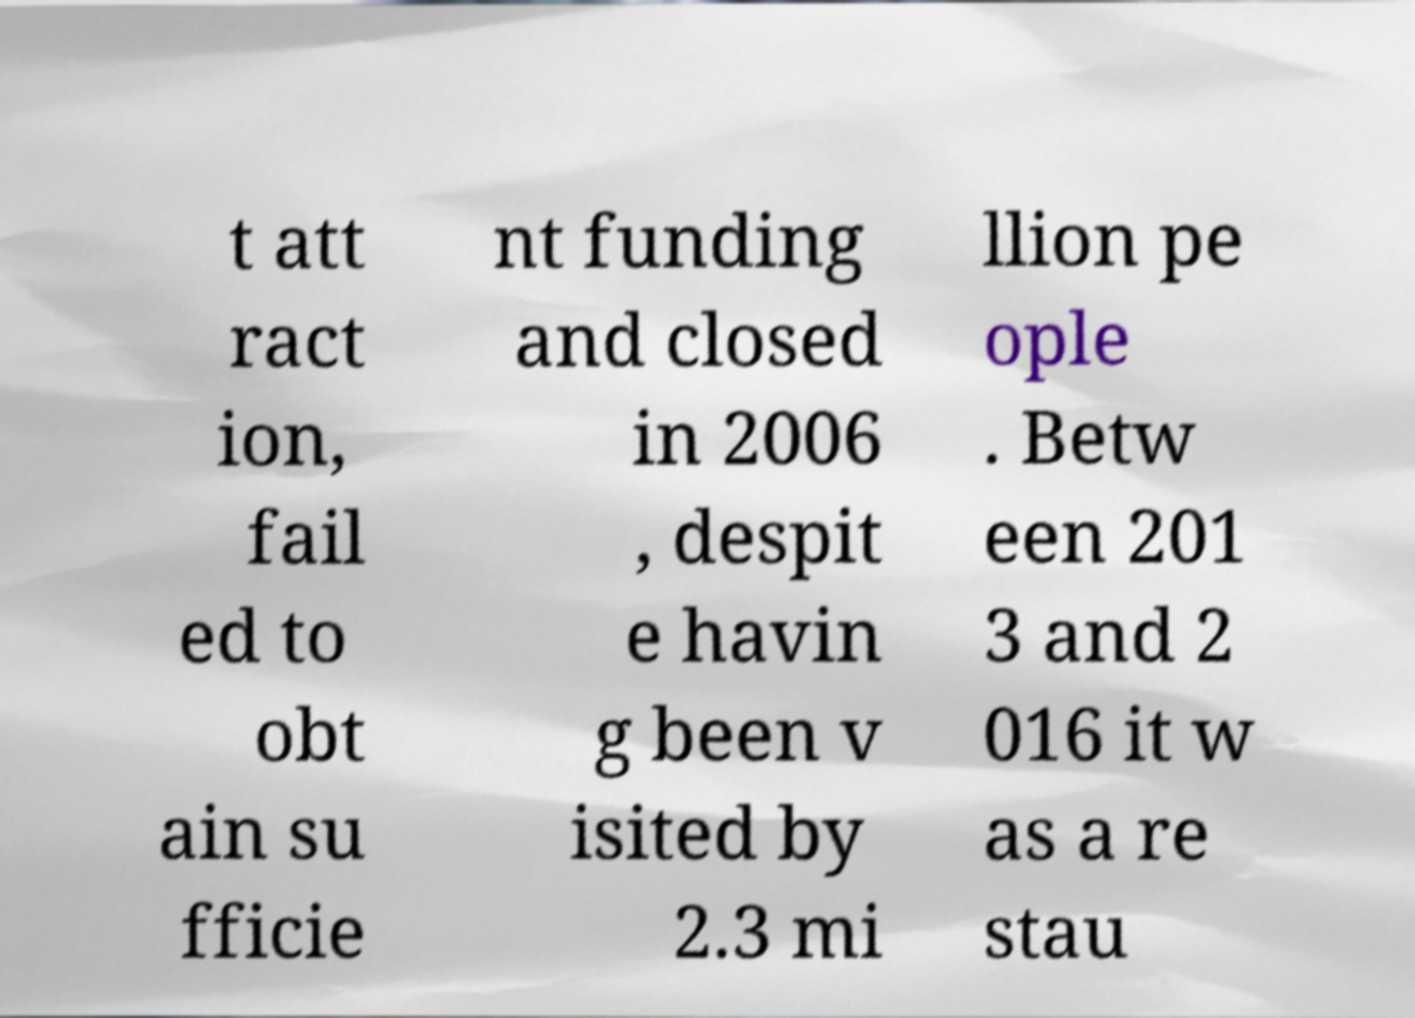For documentation purposes, I need the text within this image transcribed. Could you provide that? t att ract ion, fail ed to obt ain su fficie nt funding and closed in 2006 , despit e havin g been v isited by 2.3 mi llion pe ople . Betw een 201 3 and 2 016 it w as a re stau 